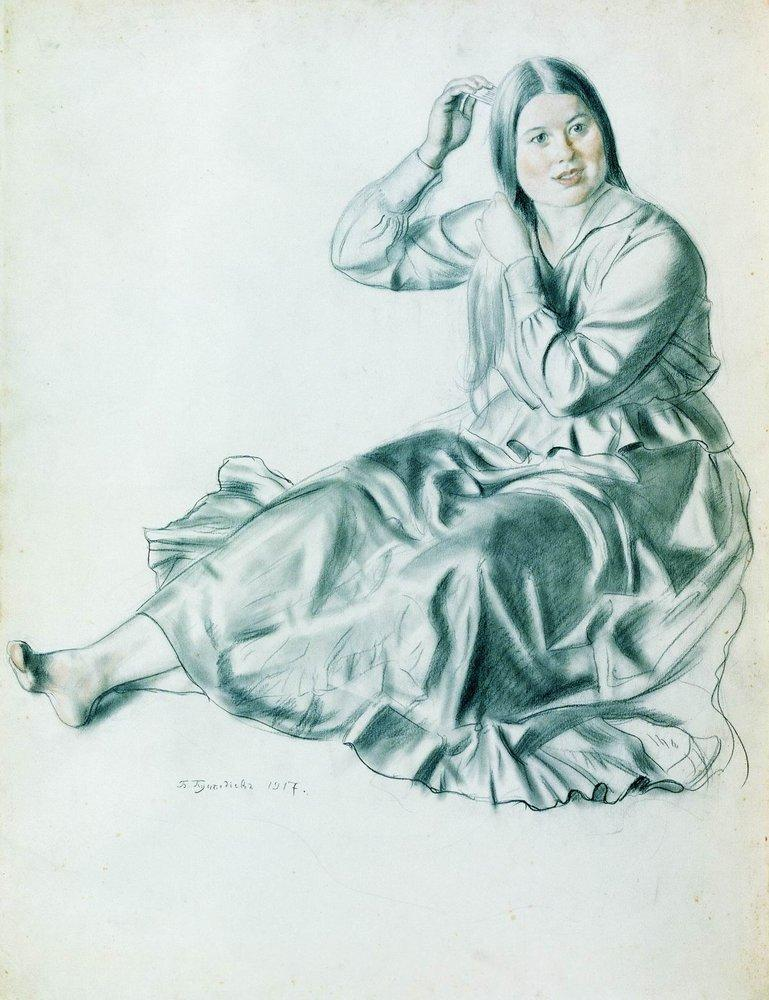Imagine a scenario where the woman has just received a letter. What might her reaction be, and how could it alter the artwork? If the woman had just received a letter, her serene and introspective expression might change to one of curiosity or excitement. The letter could be from a loved one or contain important news, adding a layer of narrative to the scene. The artist could alter the artwork to include the letter in her hand, perhaps with her gaze fixed on the words, capturing a moment of revelation or anticipation. This new element would introduce a dynamic aspect, suggesting an ongoing story beyond the tranquil moment depicted. Create a casual dialog between two people observing this image. Person A: 'This sketch is really captivating. Look at how detailed her dress is!'
Person B: 'Yeah, and her expression is so serene. I wonder what she’s thinking about.'
Person A: 'Maybe she’s lost in her thoughts, or maybe she’s just enjoying a quiet moment alone.'
Person B: 'Could be. It’s impressive how the artist captured such a peaceful vibe, don’t you think?'
Person A: 'Absolutely. You can tell a lot of care went into every stroke. And look, it’s signed by S. Zornitsa from 1917. That adds a nice historical touch.' 